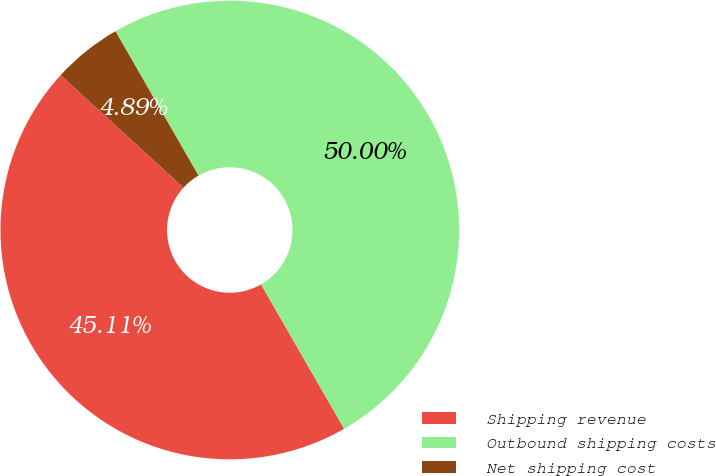Convert chart to OTSL. <chart><loc_0><loc_0><loc_500><loc_500><pie_chart><fcel>Shipping revenue<fcel>Outbound shipping costs<fcel>Net shipping cost<nl><fcel>45.11%<fcel>50.0%<fcel>4.89%<nl></chart> 